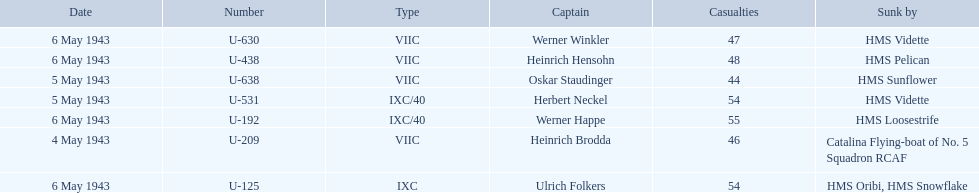Who are all of the captains? Heinrich Brodda, Oskar Staudinger, Herbert Neckel, Werner Happe, Ulrich Folkers, Werner Winkler, Heinrich Hensohn. What sunk each of the captains? Catalina Flying-boat of No. 5 Squadron RCAF, HMS Sunflower, HMS Vidette, HMS Loosestrife, HMS Oribi, HMS Snowflake, HMS Vidette, HMS Pelican. Which was sunk by the hms pelican? Heinrich Hensohn. 